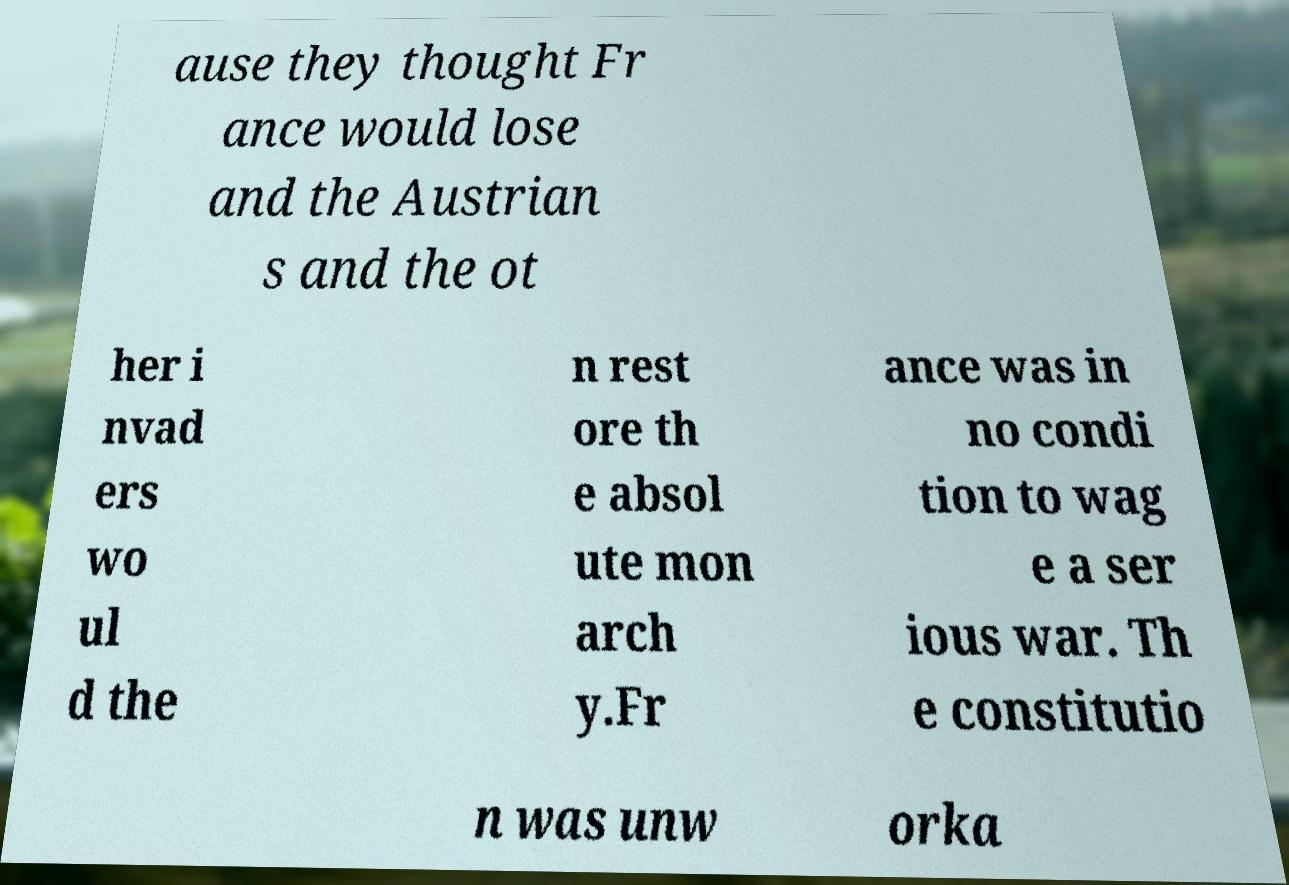For documentation purposes, I need the text within this image transcribed. Could you provide that? ause they thought Fr ance would lose and the Austrian s and the ot her i nvad ers wo ul d the n rest ore th e absol ute mon arch y.Fr ance was in no condi tion to wag e a ser ious war. Th e constitutio n was unw orka 